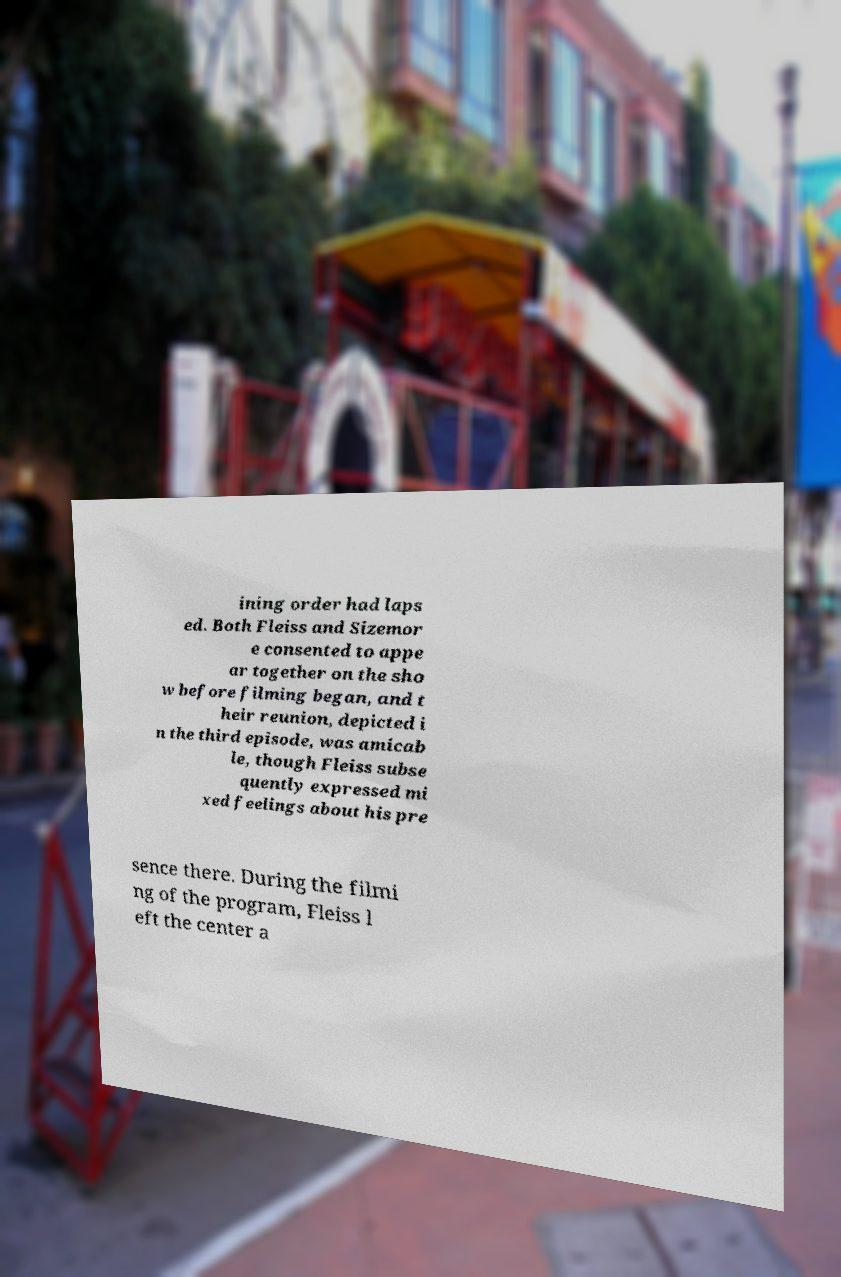What messages or text are displayed in this image? I need them in a readable, typed format. ining order had laps ed. Both Fleiss and Sizemor e consented to appe ar together on the sho w before filming began, and t heir reunion, depicted i n the third episode, was amicab le, though Fleiss subse quently expressed mi xed feelings about his pre sence there. During the filmi ng of the program, Fleiss l eft the center a 